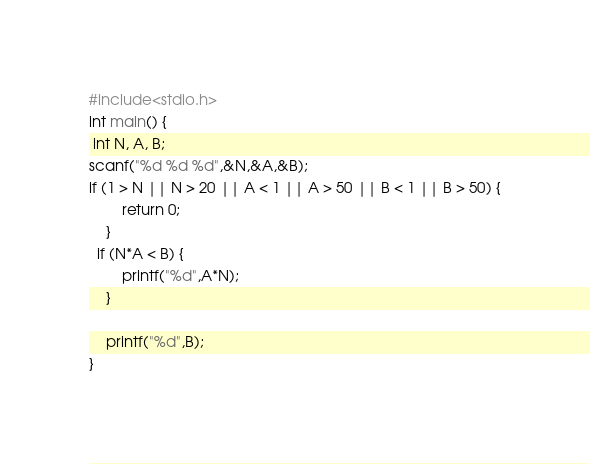Convert code to text. <code><loc_0><loc_0><loc_500><loc_500><_C_>#include<stdio.h>
int main() {
 int N, A, B;
scanf("%d %d %d",&N,&A,&B);
if (1 > N || N > 20 || A < 1 || A > 50 || B < 1 || B > 50) {
		return 0;
	}
  if (N*A < B) {
		printf("%d",A*N);
	}
	
	printf("%d",B);
}</code> 